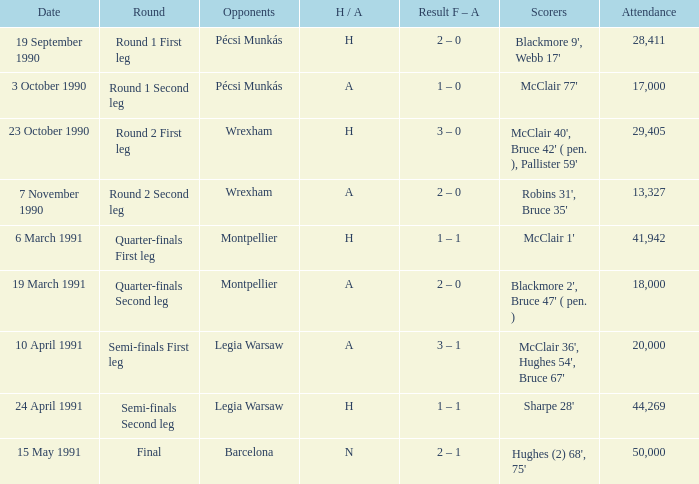What is the presence count in the final round? 50000.0. 